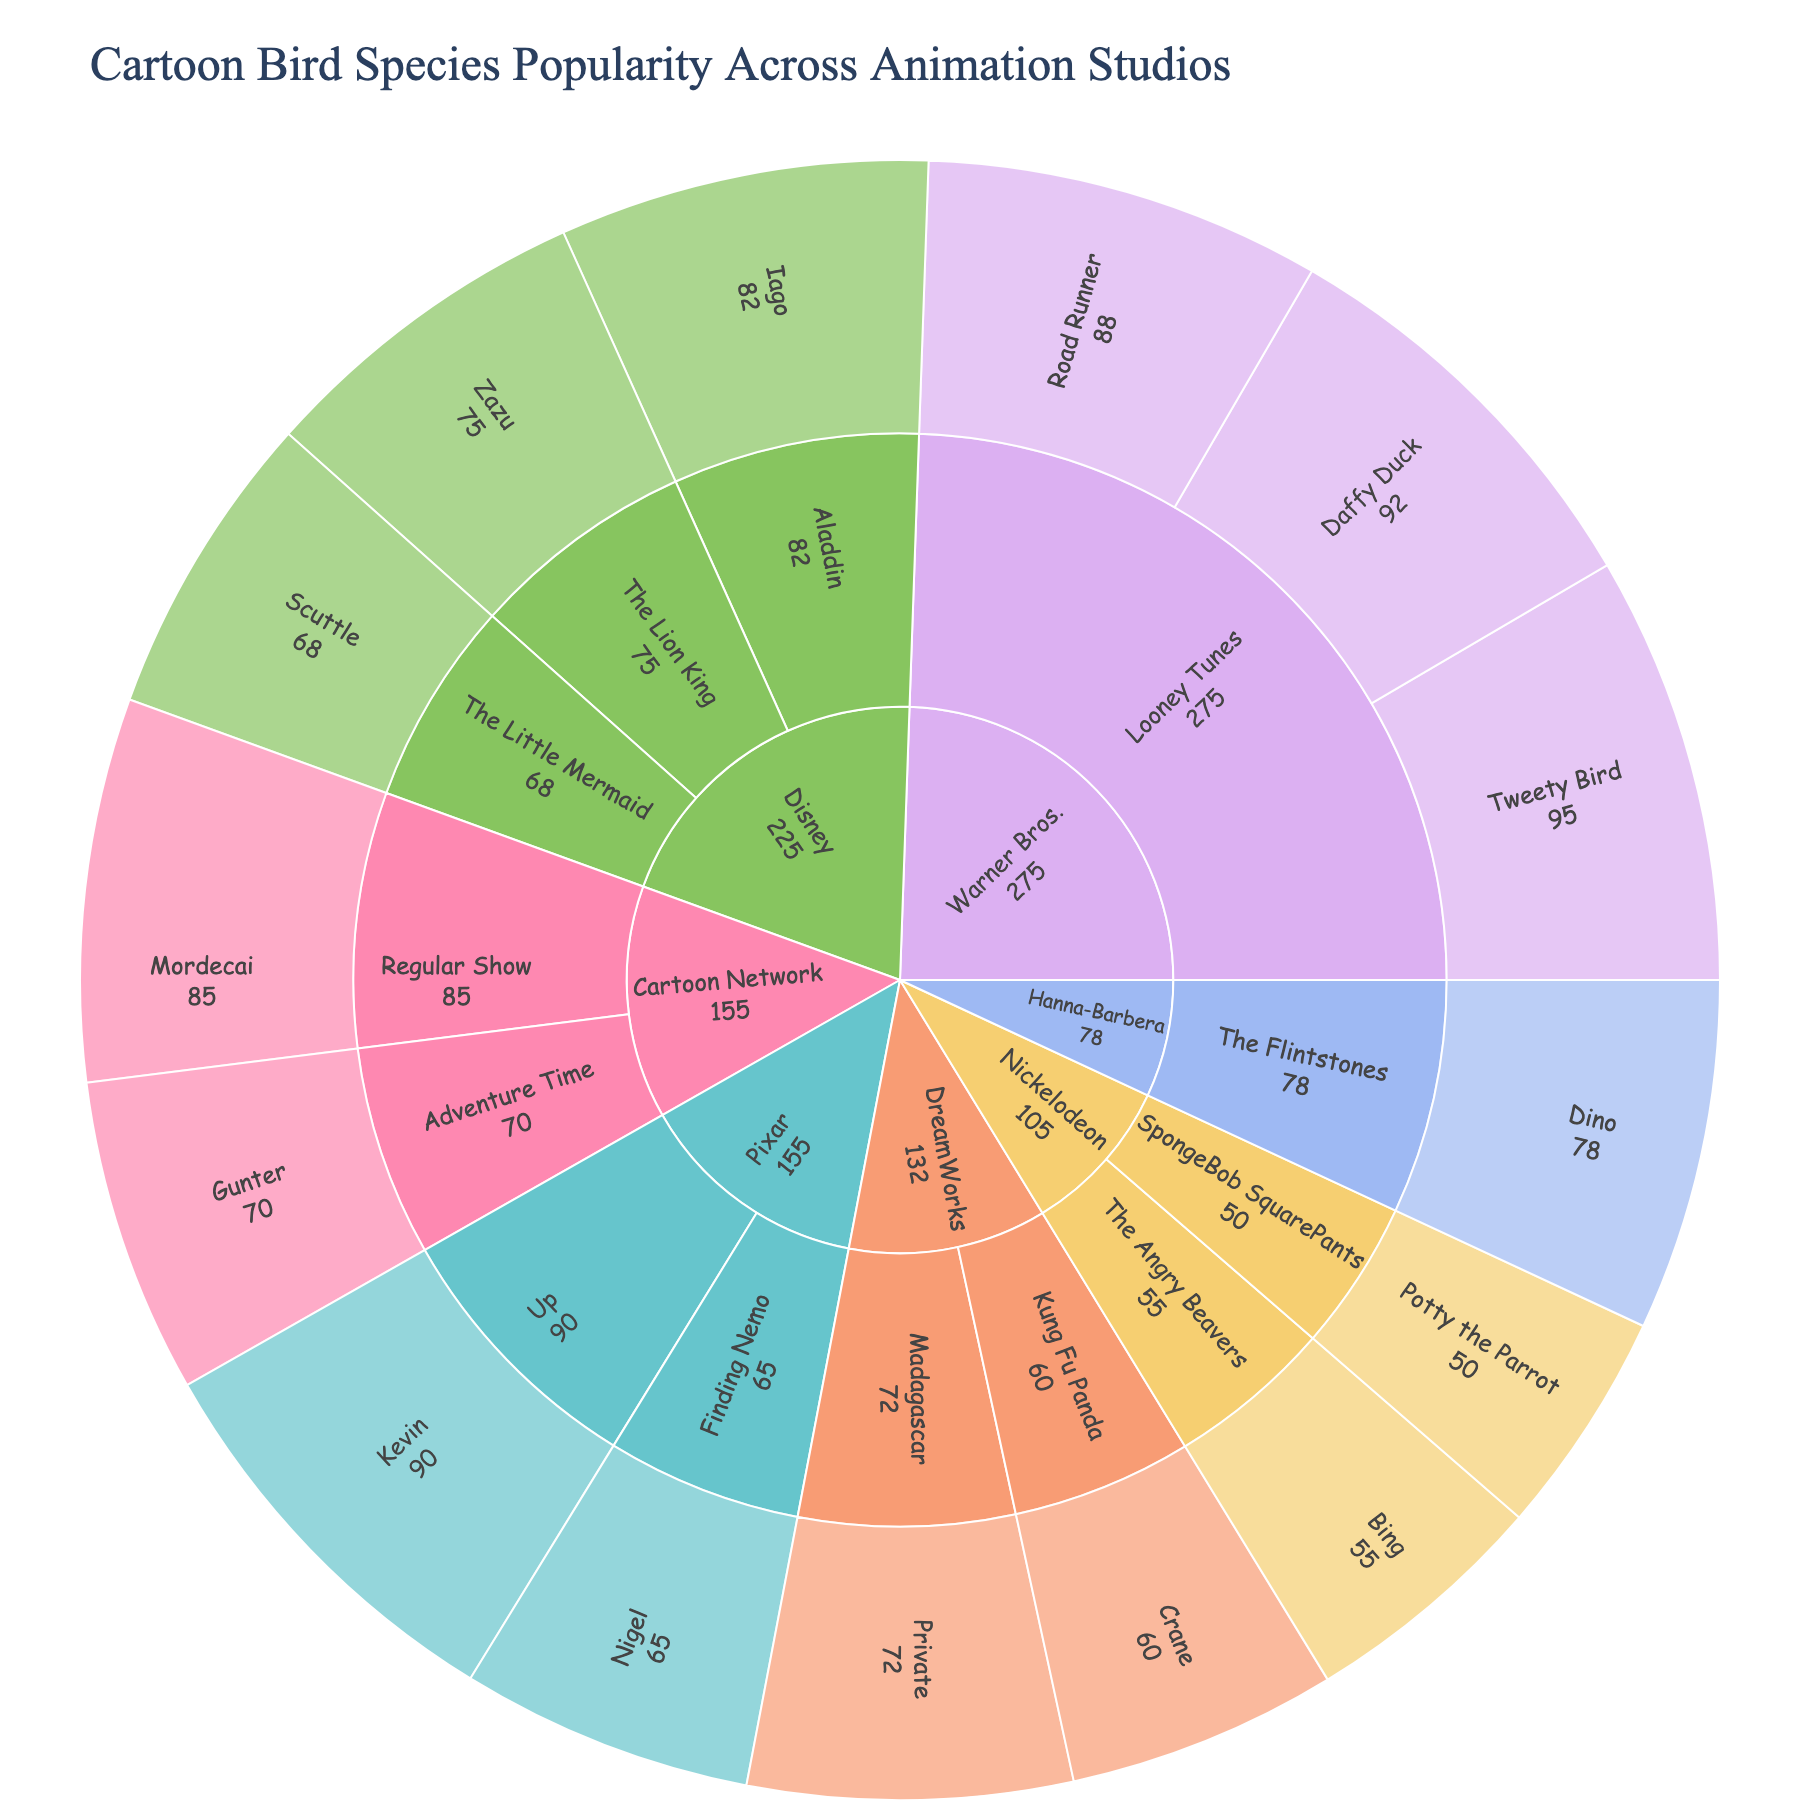What's the most popular bird character in the figure? To find the most popular bird character, look at the value representing popularity for each bird character displayed in the plot. Tweety Bird has the highest popularity value of 95.
Answer: Tweety Bird Which studio has the highest combined popularity for all its bird characters? Sum the popularity values of all bird characters under each studio: Disney (75 + 68 + 82 = 225), Pixar (90 + 65 = 155), Warner Bros. (95 + 88 + 92 = 275), Cartoon Network (85 + 70 = 155), DreamWorks (60 + 72 = 132), Nickelodeon (55 + 50 = 105), Hanna-Barbera (78). Warner Bros. has the highest total.
Answer: Warner Bros What is the total popularity for bird characters in Disney and Pixar combined? Sum the popularity values for Disney (225) and Pixar (155), giving a combined total of 225 + 155 = 380.
Answer: 380 Which series has the lowest popularity bird character, and what is its popularity value? Look at each series' bird characters and identify the lowest popularity value: "SpongeBob SquarePants" has the bird character Potty the Parrot with a popularity value of 50.
Answer: SpongeBob SquarePants, 50 Which bird character is more popular: Mordecai or Kevin? Compare the popularity values for Mordecai (85) and Kevin (90). Kevin has a higher popularity value.
Answer: Kevin Does DreamWorks have any bird characters that are more popular than Private? Check DreamWorks' characters: Crane (60) and Private (72). No bird is more popular than Private.
Answer: No What's the average popularity value of all bird characters? Sum all popularity values (75 + 68 + 82 + 90 + 65 + 95 + 88 + 92 + 85 + 70 + 60 + 72 + 55 + 50 + 78 = 1125), and divide by the number of bird characters (15). The average is 1125 / 15 = 75.
Answer: 75 Which animation studio has the most diverse range of bird characters (i.e., the most bird characters)? Count the number of bird characters per studio: Disney (3), Pixar (2), Warner Bros. (3), Cartoon Network (2), DreamWorks (2), Nickelodeon (2), Hanna-Barbera (1). Both Disney and Warner Bros. have the highest count with 3 each.
Answer: Disney and Warner Bros What is the difference in popularity between the most and least popular bird characters? Identify the most popular bird character (Tweety Bird, 95) and the least popular (Potty the Parrot, 50). The difference is 95 - 50 = 45.
Answer: 45 